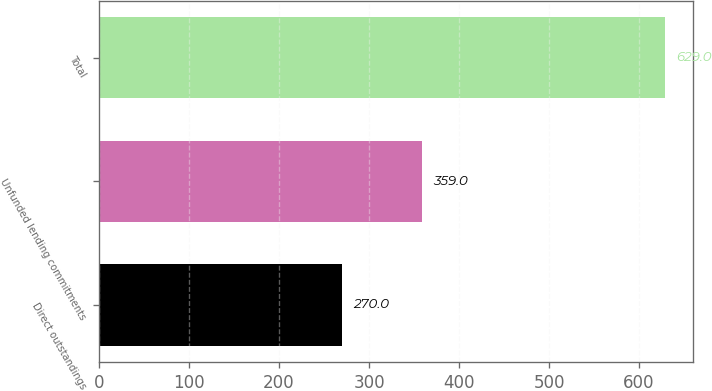<chart> <loc_0><loc_0><loc_500><loc_500><bar_chart><fcel>Direct outstandings<fcel>Unfunded lending commitments<fcel>Total<nl><fcel>270<fcel>359<fcel>629<nl></chart> 